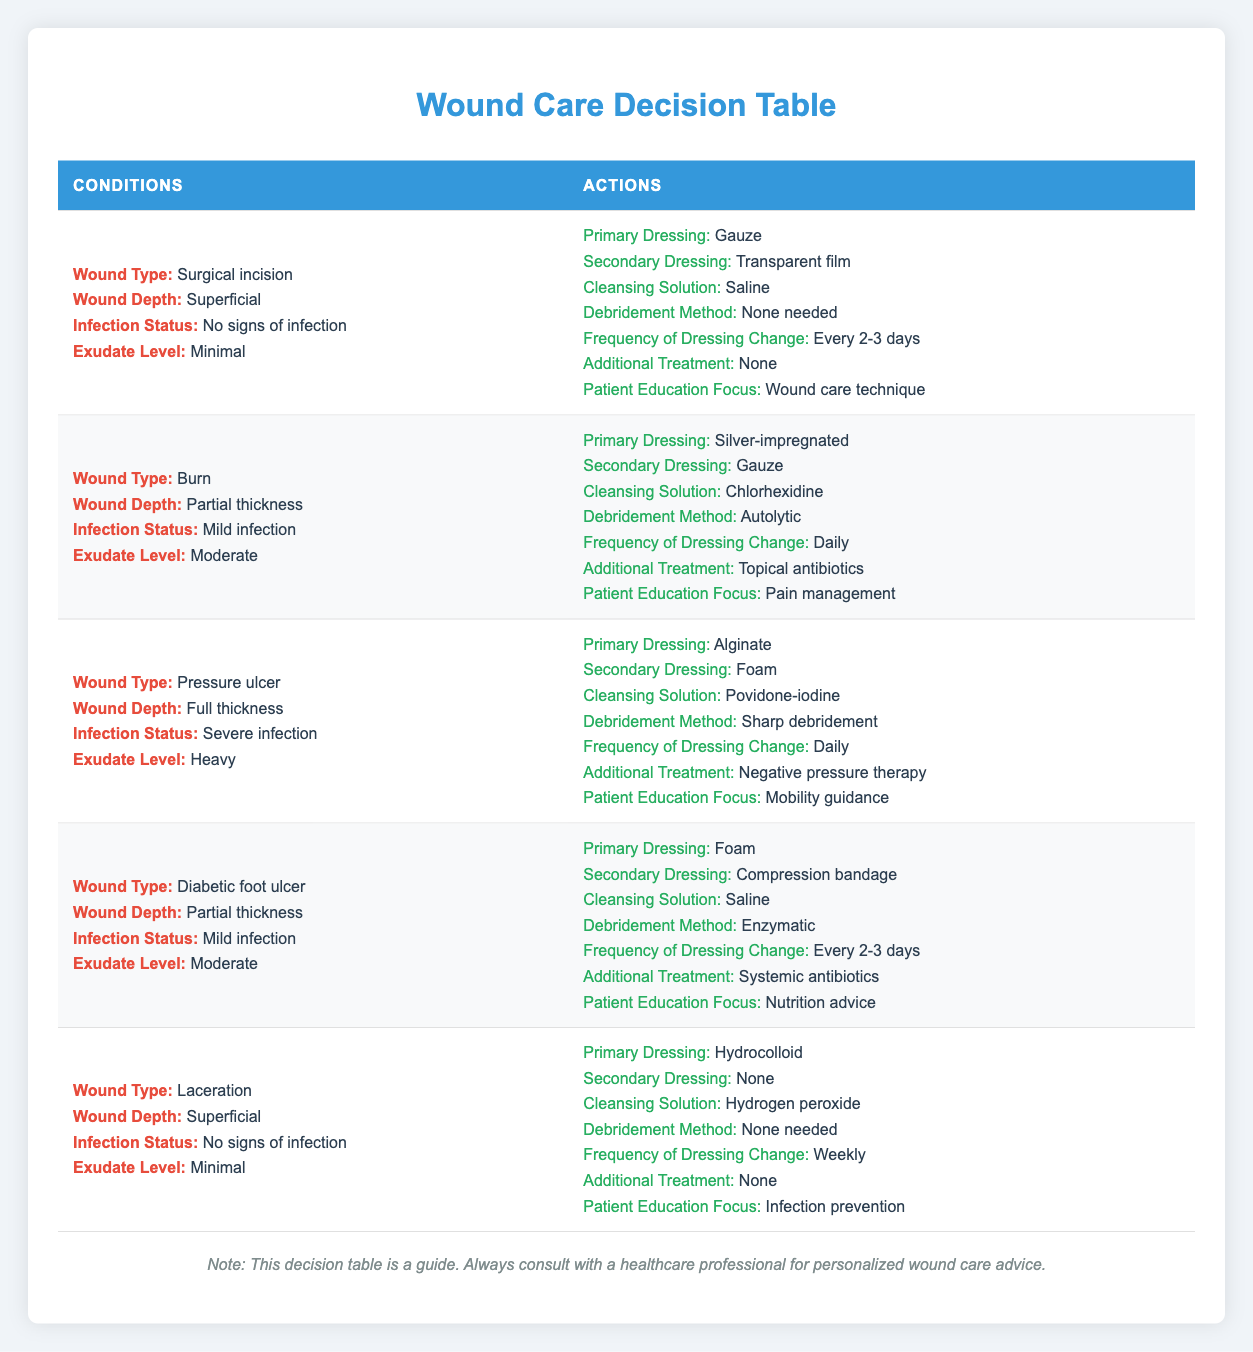What dressing is recommended for a surgical incision with minimal exudate? The table indicates that for a surgical incision with minimal exudate, the primary dressing is Gauze and the secondary dressing is a Transparent film.
Answer: Gauze, Transparent film Is daily dressing change recommended for pressure ulcers with severe infection? Yes, the table specifies that pressure ulcers with severe infection should have a dressing change frequency of Daily.
Answer: Yes What is the cleansing solution for diabetic foot ulcers with mild infection? According to the table, diabetic foot ulcers with mild infection should be cleansed with Saline.
Answer: Saline For burns with moderate exudate and mild infection, what additional treatment is recommended? The table states that for burns with moderate exudate and mild infection, the additional treatment recommended is Topical antibiotics.
Answer: Topical antibiotics Which wound type is treated with Alginate as the primary dressing? The table shows that Alginate is used as the primary dressing for pressure ulcers with heavy exudate and severe infection.
Answer: Pressure ulcer If a wound has full thickness and severe infection, what are the recommended treatments? For a wound classified as full thickness and severe infection, the recommendations in the table are: Primary Dressing - Alginate, Secondary Dressing - Foam, Cleansing Solution - Povidone-iodine, Debridement Method - Sharp debridement, Frequency of Dressing Change - Daily, Additional Treatment - Negative pressure therapy, and Patient Education Focus - Mobility guidance.
Answer: Alginate, Foam, Povidone-iodine, Sharp debridement, Daily, Negative pressure therapy, Mobility guidance How many treatment options recommend a frequency of dressing change every 2-3 days? The table indicates that there are two instances recommending every 2-3 days: for surgical incisions and diabetic foot ulcers with partial thickness and mild infection.
Answer: 2 Is the patient education focus the same for surgical incisions with minimal exudate and diabetic foot ulcers with partial thickness? No, surgical incision patient education focuses on wound care technique while diabetic foot ulcer education focuses on nutrition advice.
Answer: No What is the primary dressing for a laceration with minimal exudate? For a laceration with minimal exudate, the table states that Hydrocolloid is used as the primary dressing.
Answer: Hydrocolloid 